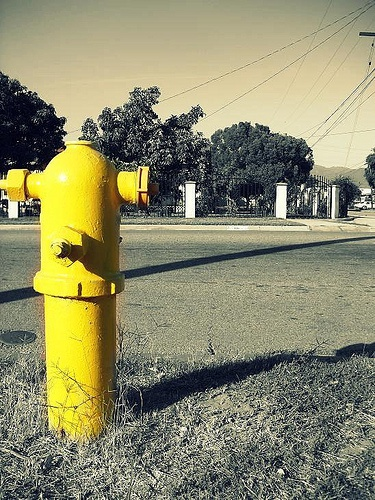Describe the objects in this image and their specific colors. I can see fire hydrant in gray, yellow, maroon, and olive tones and car in gray, ivory, black, and darkgray tones in this image. 